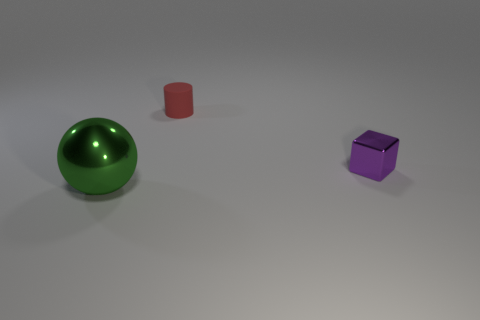Is there anything else that has the same material as the red cylinder?
Ensure brevity in your answer.  No. The purple object that is made of the same material as the green object is what size?
Your answer should be very brief. Small. Are there any shiny objects left of the small purple shiny cube?
Offer a very short reply. Yes. There is a object that is on the right side of the red matte cylinder to the left of the metal thing that is behind the green shiny object; how big is it?
Make the answer very short. Small. What material is the big sphere?
Your answer should be compact. Metal. There is a small object that is behind the tiny object that is on the right side of the object behind the tiny shiny object; what is it made of?
Ensure brevity in your answer.  Rubber. How many metallic objects are there?
Ensure brevity in your answer.  2. What number of yellow things are metal objects or balls?
Provide a succinct answer. 0. How many other objects are the same shape as the green shiny thing?
Make the answer very short. 0. How many large objects are rubber things or blocks?
Provide a short and direct response. 0. 